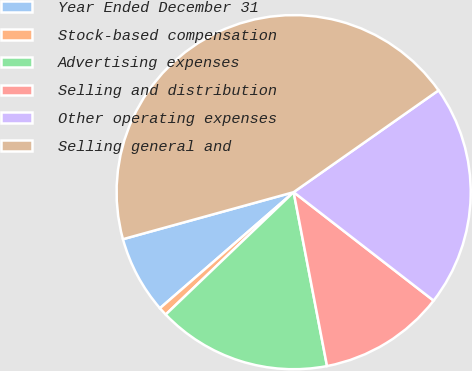<chart> <loc_0><loc_0><loc_500><loc_500><pie_chart><fcel>Year Ended December 31<fcel>Stock-based compensation<fcel>Advertising expenses<fcel>Selling and distribution<fcel>Other operating expenses<fcel>Selling general and<nl><fcel>7.1%<fcel>0.77%<fcel>15.87%<fcel>11.49%<fcel>20.24%<fcel>44.53%<nl></chart> 